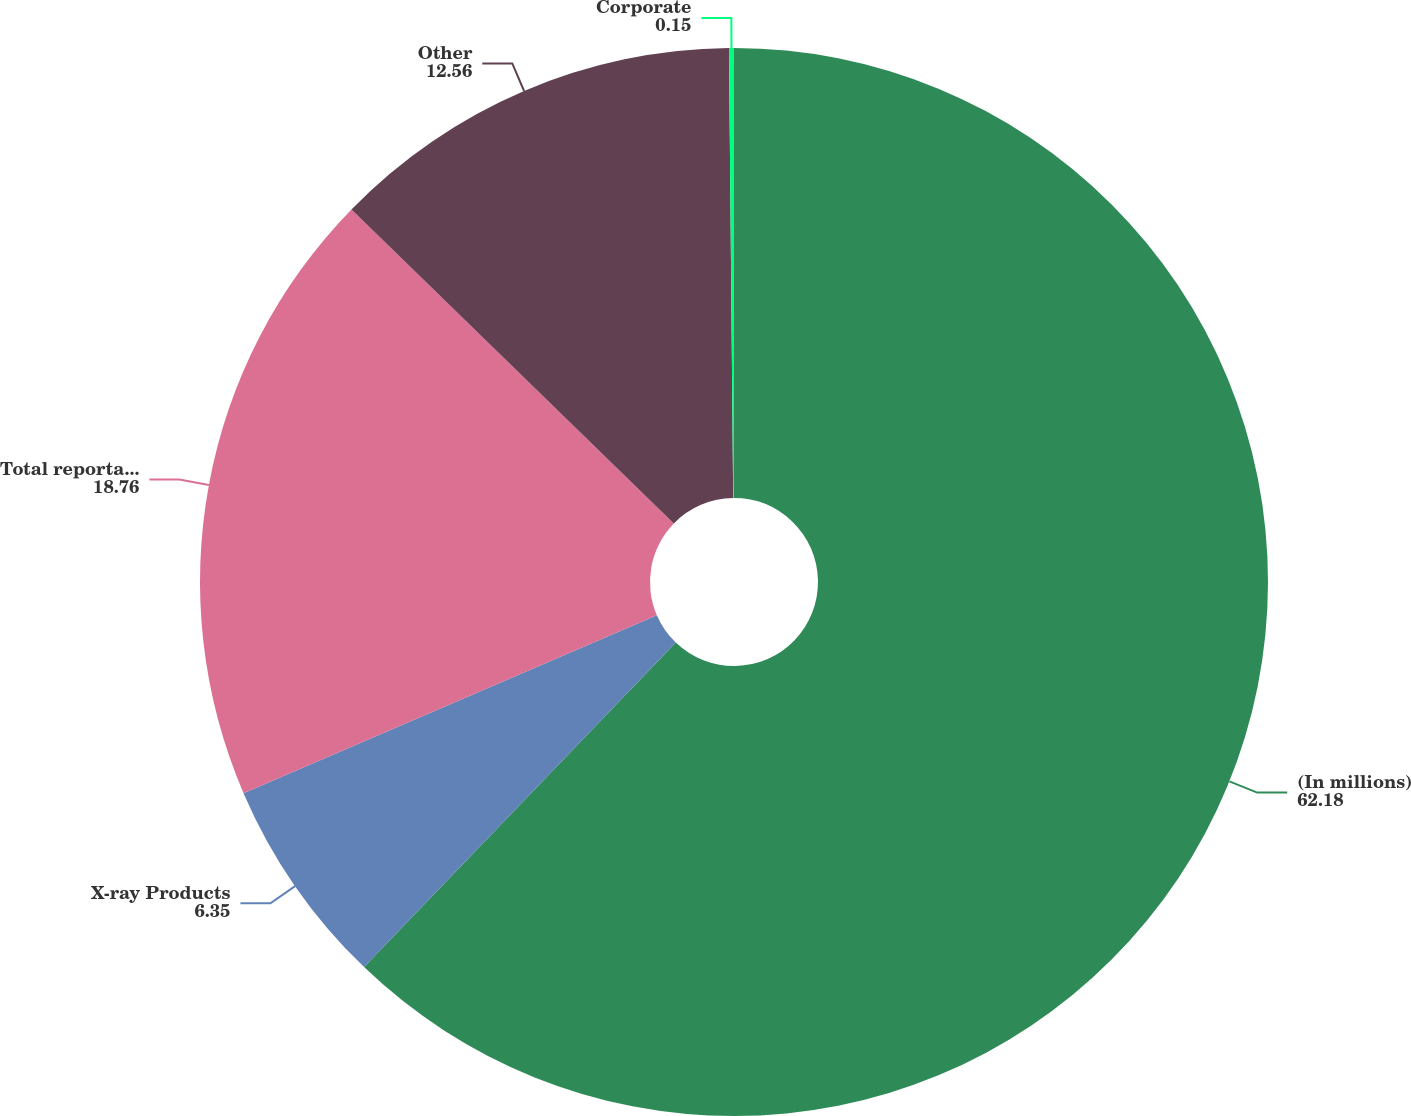Convert chart to OTSL. <chart><loc_0><loc_0><loc_500><loc_500><pie_chart><fcel>(In millions)<fcel>X-ray Products<fcel>Total reportable segments<fcel>Other<fcel>Corporate<nl><fcel>62.18%<fcel>6.35%<fcel>18.76%<fcel>12.56%<fcel>0.15%<nl></chart> 